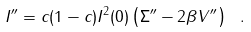<formula> <loc_0><loc_0><loc_500><loc_500>I ^ { \prime \prime } = c ( 1 - c ) I ^ { 2 } ( 0 ) \left ( \Sigma ^ { \prime \prime } - 2 \beta V ^ { \prime \prime } \right ) \ .</formula> 